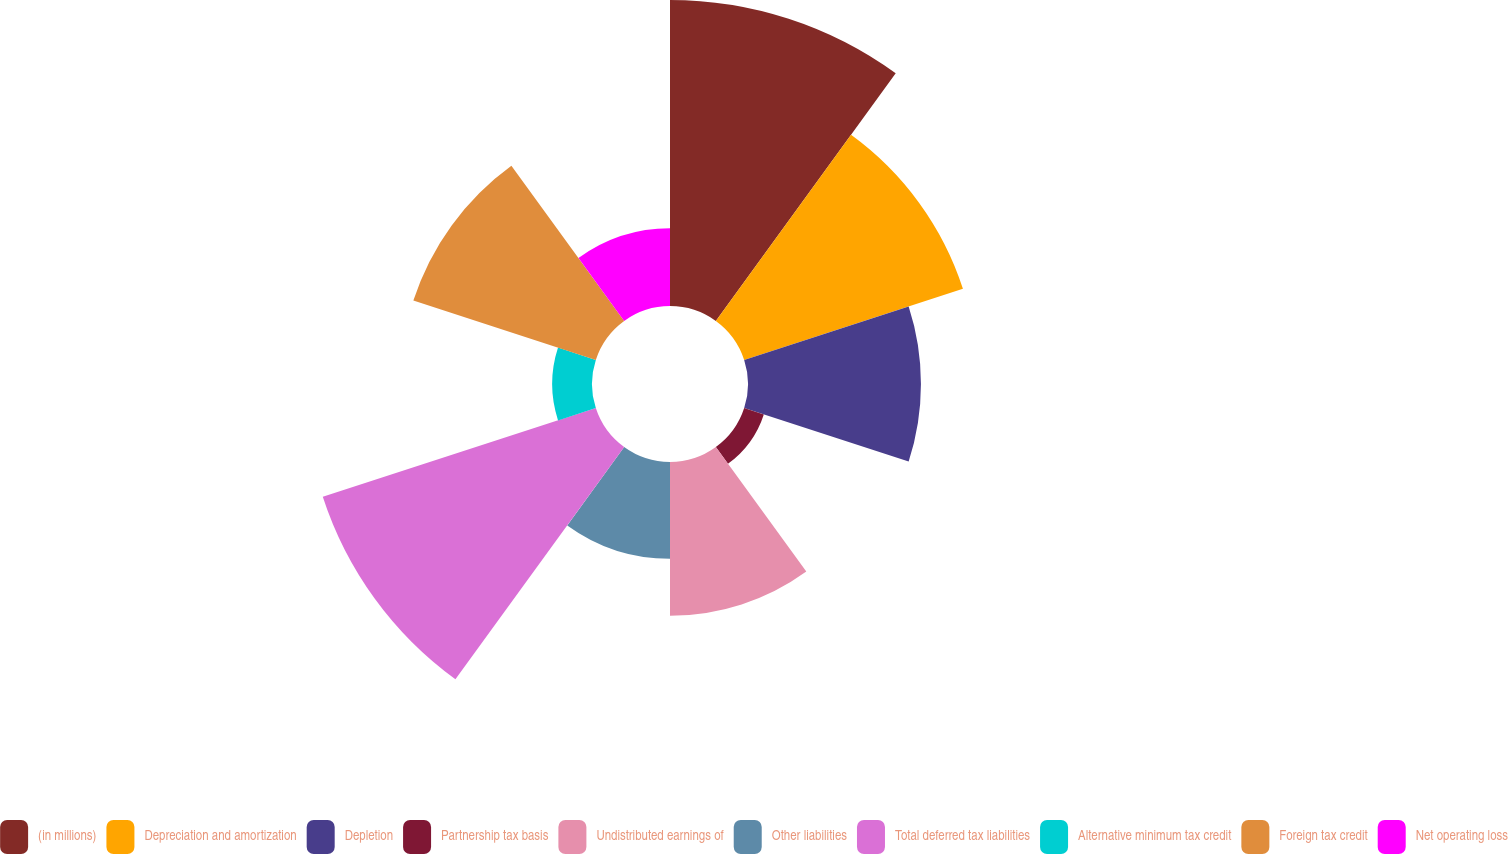Convert chart to OTSL. <chart><loc_0><loc_0><loc_500><loc_500><pie_chart><fcel>(in millions)<fcel>Depreciation and amortization<fcel>Depletion<fcel>Partnership tax basis<fcel>Undistributed earnings of<fcel>Other liabilities<fcel>Total deferred tax liabilities<fcel>Alternative minimum tax credit<fcel>Foreign tax credit<fcel>Net operating loss<nl><fcel>19.41%<fcel>14.59%<fcel>10.97%<fcel>1.31%<fcel>9.76%<fcel>6.14%<fcel>18.21%<fcel>2.52%<fcel>12.17%<fcel>4.93%<nl></chart> 